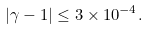Convert formula to latex. <formula><loc_0><loc_0><loc_500><loc_500>| \gamma - 1 | \leq 3 \times 1 0 ^ { - 4 } .</formula> 